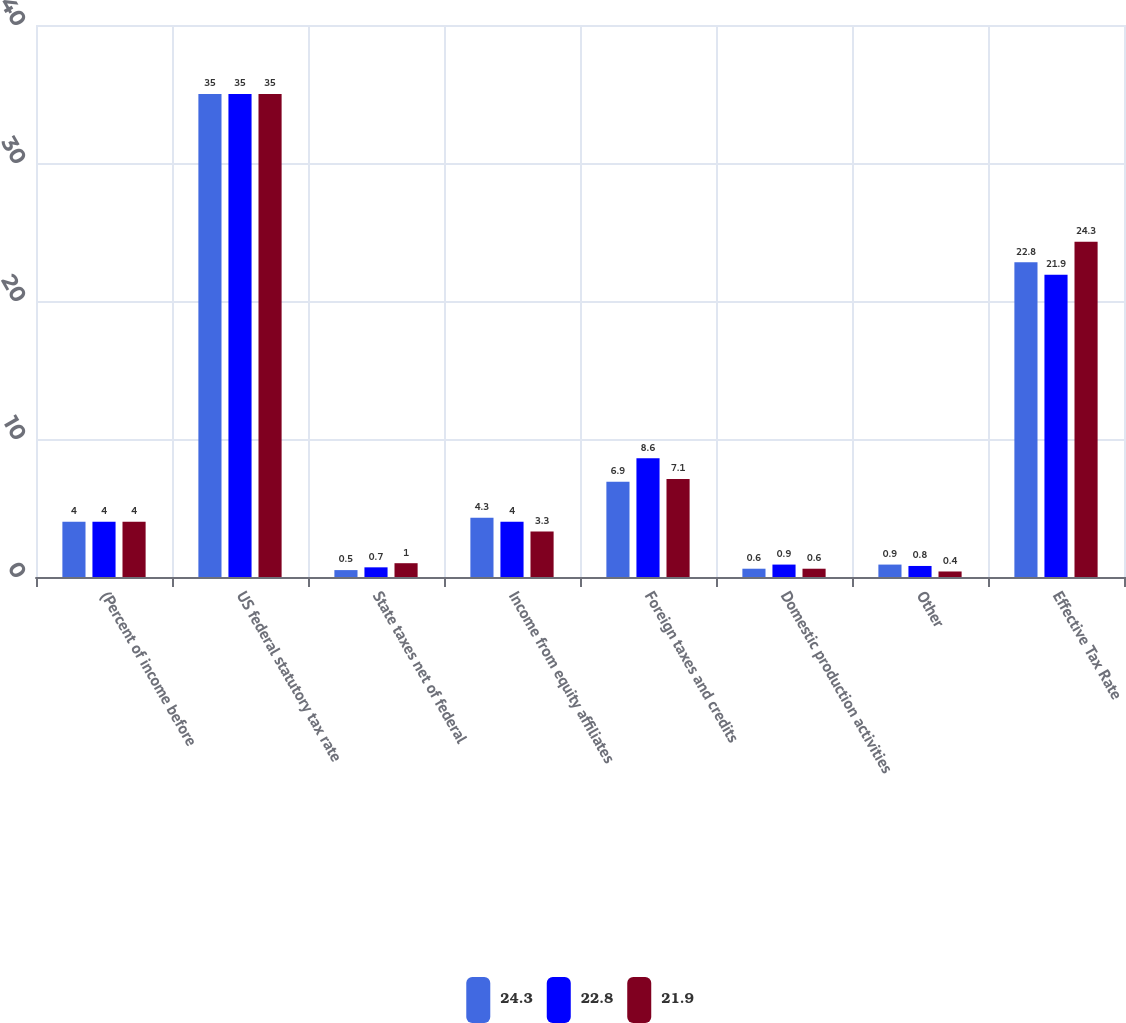<chart> <loc_0><loc_0><loc_500><loc_500><stacked_bar_chart><ecel><fcel>(Percent of income before<fcel>US federal statutory tax rate<fcel>State taxes net of federal<fcel>Income from equity affiliates<fcel>Foreign taxes and credits<fcel>Domestic production activities<fcel>Other<fcel>Effective Tax Rate<nl><fcel>24.3<fcel>4<fcel>35<fcel>0.5<fcel>4.3<fcel>6.9<fcel>0.6<fcel>0.9<fcel>22.8<nl><fcel>22.8<fcel>4<fcel>35<fcel>0.7<fcel>4<fcel>8.6<fcel>0.9<fcel>0.8<fcel>21.9<nl><fcel>21.9<fcel>4<fcel>35<fcel>1<fcel>3.3<fcel>7.1<fcel>0.6<fcel>0.4<fcel>24.3<nl></chart> 